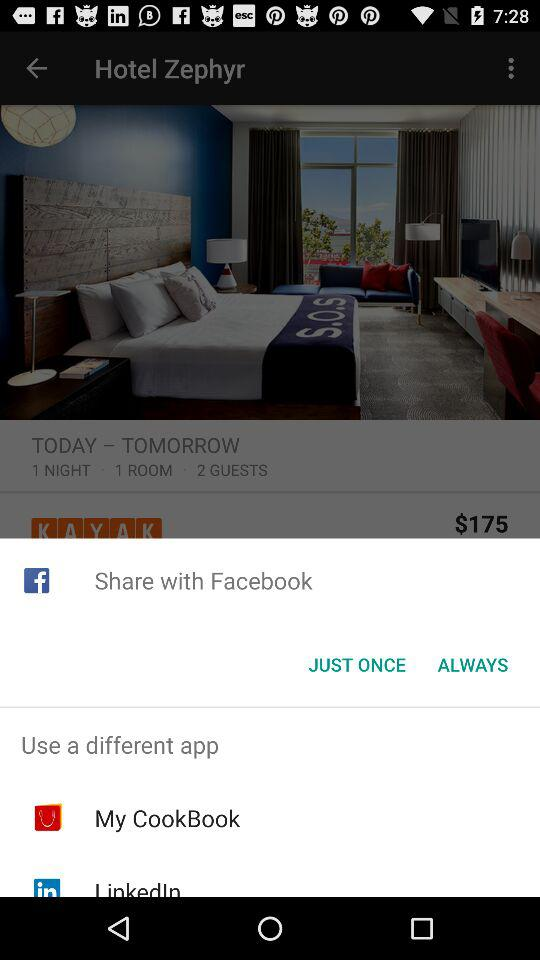What is the room rate for one night? The room rate is $175 for one night. 